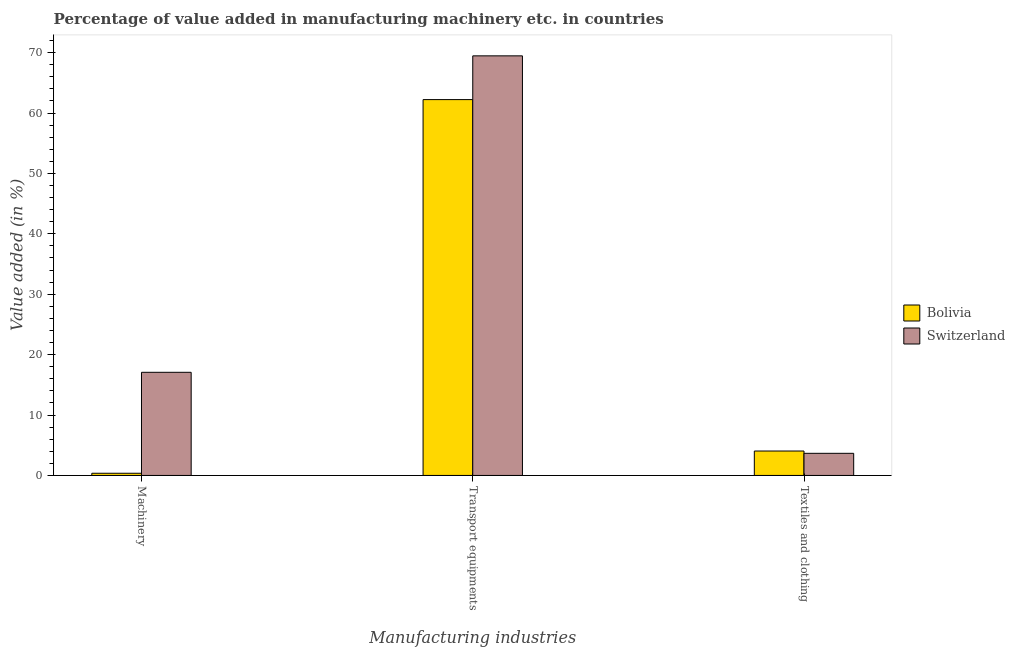How many groups of bars are there?
Provide a succinct answer. 3. Are the number of bars per tick equal to the number of legend labels?
Give a very brief answer. Yes. How many bars are there on the 2nd tick from the left?
Ensure brevity in your answer.  2. What is the label of the 1st group of bars from the left?
Give a very brief answer. Machinery. What is the value added in manufacturing machinery in Bolivia?
Your answer should be very brief. 0.36. Across all countries, what is the maximum value added in manufacturing machinery?
Make the answer very short. 17.07. Across all countries, what is the minimum value added in manufacturing transport equipments?
Your answer should be compact. 62.22. In which country was the value added in manufacturing transport equipments maximum?
Your answer should be compact. Switzerland. What is the total value added in manufacturing textile and clothing in the graph?
Your answer should be very brief. 7.7. What is the difference between the value added in manufacturing transport equipments in Switzerland and that in Bolivia?
Your answer should be very brief. 7.24. What is the difference between the value added in manufacturing transport equipments in Bolivia and the value added in manufacturing machinery in Switzerland?
Provide a succinct answer. 45.15. What is the average value added in manufacturing machinery per country?
Provide a succinct answer. 8.72. What is the difference between the value added in manufacturing textile and clothing and value added in manufacturing machinery in Switzerland?
Make the answer very short. -13.41. What is the ratio of the value added in manufacturing machinery in Switzerland to that in Bolivia?
Provide a succinct answer. 47.11. Is the difference between the value added in manufacturing machinery in Bolivia and Switzerland greater than the difference between the value added in manufacturing textile and clothing in Bolivia and Switzerland?
Offer a very short reply. No. What is the difference between the highest and the second highest value added in manufacturing textile and clothing?
Provide a short and direct response. 0.38. What is the difference between the highest and the lowest value added in manufacturing machinery?
Provide a short and direct response. 16.71. What does the 2nd bar from the left in Transport equipments represents?
Your response must be concise. Switzerland. Is it the case that in every country, the sum of the value added in manufacturing machinery and value added in manufacturing transport equipments is greater than the value added in manufacturing textile and clothing?
Offer a very short reply. Yes. Are all the bars in the graph horizontal?
Give a very brief answer. No. What is the difference between two consecutive major ticks on the Y-axis?
Your answer should be very brief. 10. Are the values on the major ticks of Y-axis written in scientific E-notation?
Offer a terse response. No. Does the graph contain grids?
Provide a short and direct response. No. What is the title of the graph?
Provide a short and direct response. Percentage of value added in manufacturing machinery etc. in countries. What is the label or title of the X-axis?
Provide a succinct answer. Manufacturing industries. What is the label or title of the Y-axis?
Offer a terse response. Value added (in %). What is the Value added (in %) in Bolivia in Machinery?
Make the answer very short. 0.36. What is the Value added (in %) in Switzerland in Machinery?
Keep it short and to the point. 17.07. What is the Value added (in %) in Bolivia in Transport equipments?
Offer a terse response. 62.22. What is the Value added (in %) in Switzerland in Transport equipments?
Your answer should be compact. 69.46. What is the Value added (in %) in Bolivia in Textiles and clothing?
Offer a very short reply. 4.04. What is the Value added (in %) of Switzerland in Textiles and clothing?
Your answer should be very brief. 3.66. Across all Manufacturing industries, what is the maximum Value added (in %) in Bolivia?
Your answer should be very brief. 62.22. Across all Manufacturing industries, what is the maximum Value added (in %) of Switzerland?
Make the answer very short. 69.46. Across all Manufacturing industries, what is the minimum Value added (in %) in Bolivia?
Provide a succinct answer. 0.36. Across all Manufacturing industries, what is the minimum Value added (in %) of Switzerland?
Keep it short and to the point. 3.66. What is the total Value added (in %) of Bolivia in the graph?
Offer a terse response. 66.63. What is the total Value added (in %) in Switzerland in the graph?
Ensure brevity in your answer.  90.2. What is the difference between the Value added (in %) of Bolivia in Machinery and that in Transport equipments?
Make the answer very short. -61.86. What is the difference between the Value added (in %) in Switzerland in Machinery and that in Transport equipments?
Your answer should be compact. -52.39. What is the difference between the Value added (in %) in Bolivia in Machinery and that in Textiles and clothing?
Keep it short and to the point. -3.68. What is the difference between the Value added (in %) in Switzerland in Machinery and that in Textiles and clothing?
Your answer should be compact. 13.41. What is the difference between the Value added (in %) of Bolivia in Transport equipments and that in Textiles and clothing?
Your answer should be compact. 58.18. What is the difference between the Value added (in %) in Switzerland in Transport equipments and that in Textiles and clothing?
Give a very brief answer. 65.8. What is the difference between the Value added (in %) of Bolivia in Machinery and the Value added (in %) of Switzerland in Transport equipments?
Your answer should be compact. -69.1. What is the difference between the Value added (in %) in Bolivia in Machinery and the Value added (in %) in Switzerland in Textiles and clothing?
Ensure brevity in your answer.  -3.3. What is the difference between the Value added (in %) in Bolivia in Transport equipments and the Value added (in %) in Switzerland in Textiles and clothing?
Provide a short and direct response. 58.56. What is the average Value added (in %) of Bolivia per Manufacturing industries?
Give a very brief answer. 22.21. What is the average Value added (in %) of Switzerland per Manufacturing industries?
Provide a short and direct response. 30.07. What is the difference between the Value added (in %) of Bolivia and Value added (in %) of Switzerland in Machinery?
Offer a terse response. -16.71. What is the difference between the Value added (in %) of Bolivia and Value added (in %) of Switzerland in Transport equipments?
Offer a very short reply. -7.24. What is the difference between the Value added (in %) of Bolivia and Value added (in %) of Switzerland in Textiles and clothing?
Offer a very short reply. 0.38. What is the ratio of the Value added (in %) in Bolivia in Machinery to that in Transport equipments?
Provide a succinct answer. 0.01. What is the ratio of the Value added (in %) of Switzerland in Machinery to that in Transport equipments?
Provide a short and direct response. 0.25. What is the ratio of the Value added (in %) of Bolivia in Machinery to that in Textiles and clothing?
Your response must be concise. 0.09. What is the ratio of the Value added (in %) in Switzerland in Machinery to that in Textiles and clothing?
Ensure brevity in your answer.  4.66. What is the ratio of the Value added (in %) in Bolivia in Transport equipments to that in Textiles and clothing?
Offer a terse response. 15.39. What is the ratio of the Value added (in %) of Switzerland in Transport equipments to that in Textiles and clothing?
Offer a terse response. 18.97. What is the difference between the highest and the second highest Value added (in %) of Bolivia?
Provide a short and direct response. 58.18. What is the difference between the highest and the second highest Value added (in %) of Switzerland?
Provide a short and direct response. 52.39. What is the difference between the highest and the lowest Value added (in %) in Bolivia?
Ensure brevity in your answer.  61.86. What is the difference between the highest and the lowest Value added (in %) of Switzerland?
Keep it short and to the point. 65.8. 